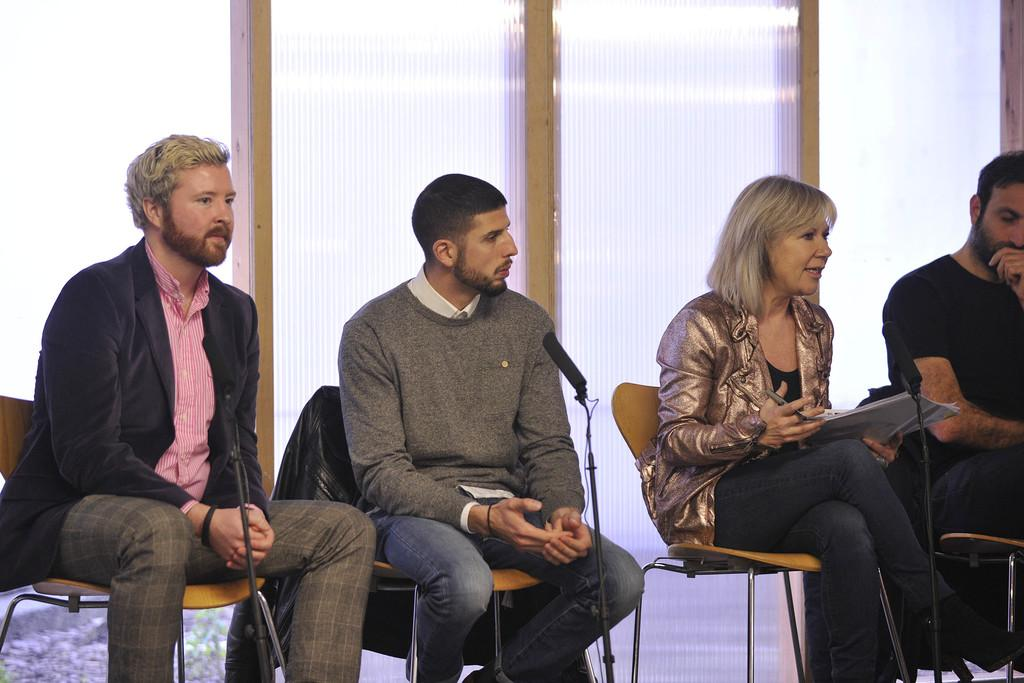How many people are in the image? There are four persons in the foreground of the image. What are the persons doing in the image? The persons are sitting on chairs and in front of microphones. What can be seen in the background of the image? There is a glass wall in the background of the image. What is the weight of the cows in the image? There are no cows present in the image, so their weight cannot be determined. 